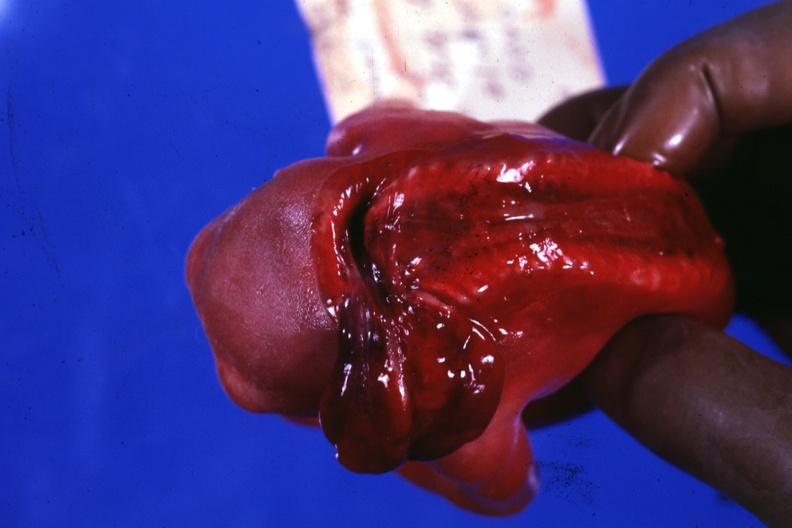does this image show posterior view to show open cord?
Answer the question using a single word or phrase. Yes 